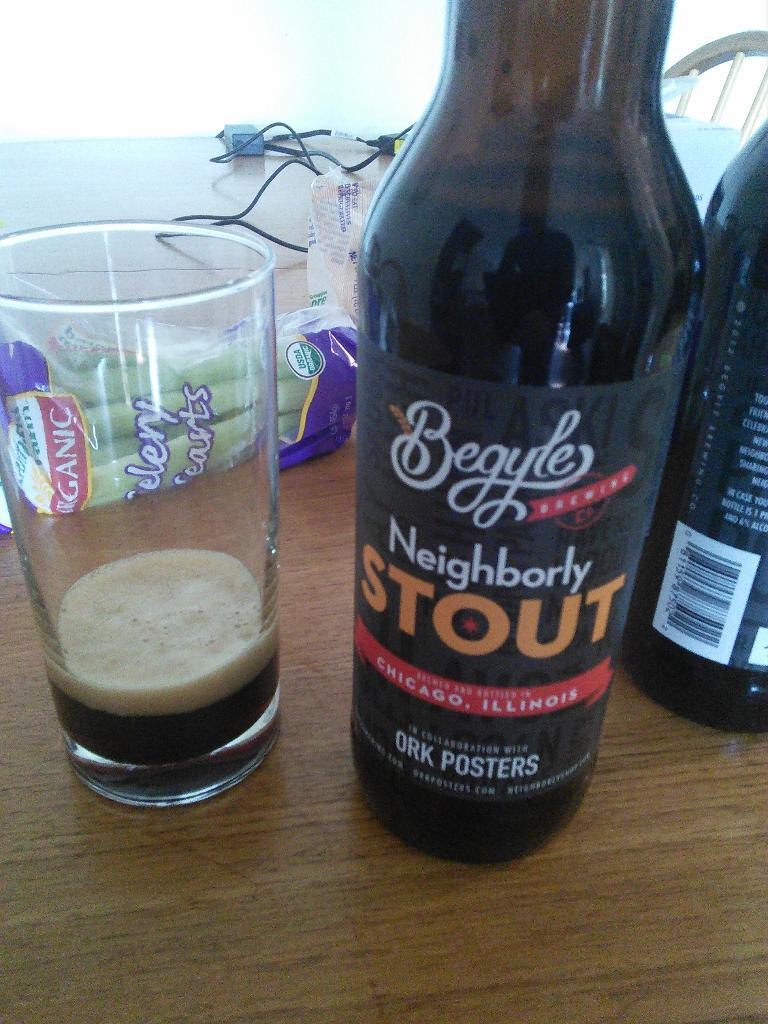What is present on the left side of the image? There is a wine glass on the left side of the image. What is unique about the wine glass? The wine glass has a sticker on it. What might be contained in the wine glass? The contents of the wine glass are not visible in the image, but it is typically used for holding wine. What type of attraction can be seen in the background of the image? There is no attraction visible in the image; it only features a wine glass with a sticker on it. 